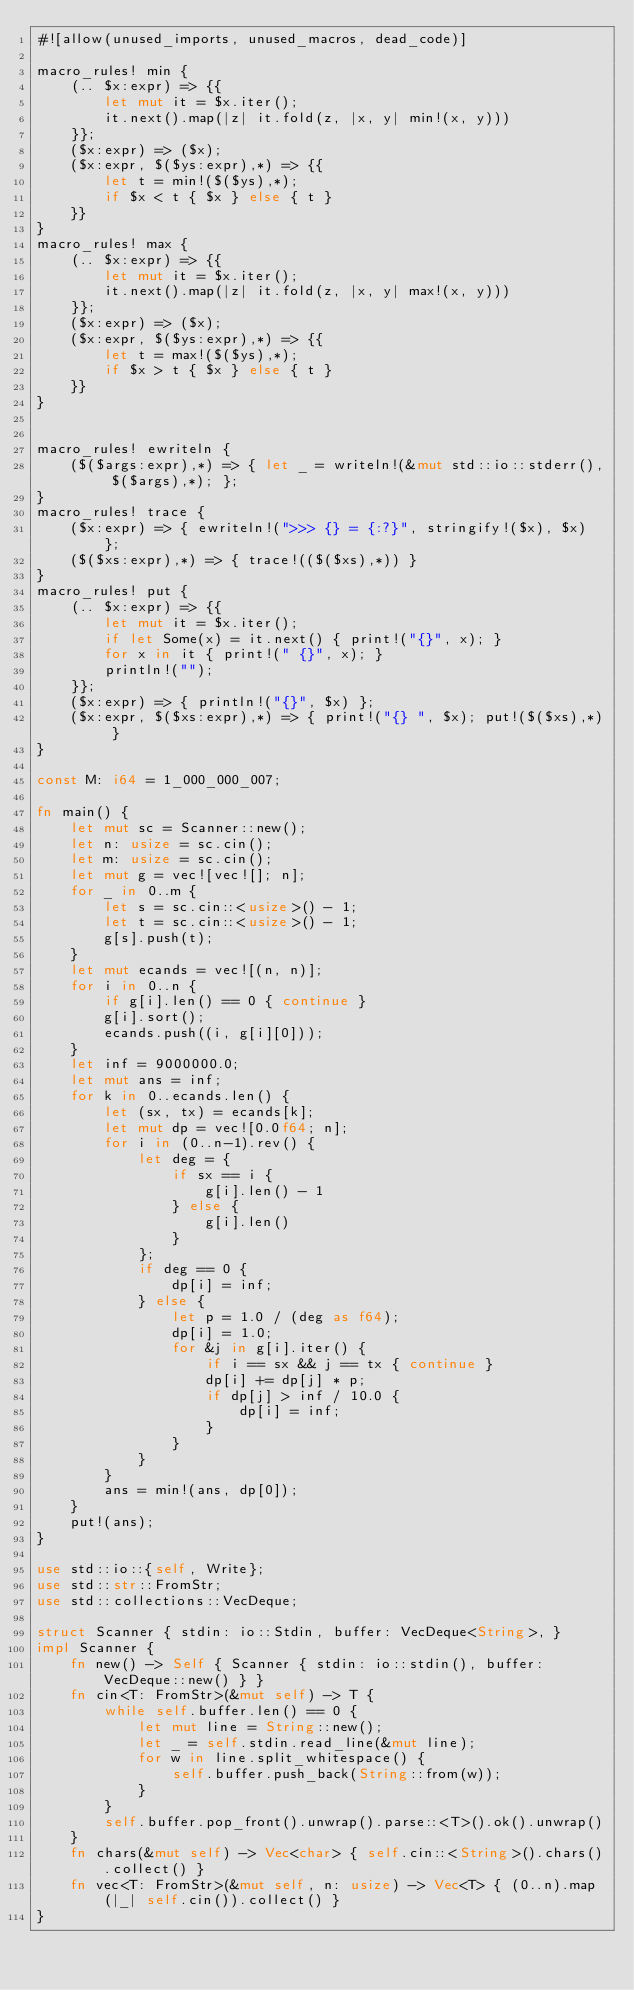Convert code to text. <code><loc_0><loc_0><loc_500><loc_500><_Rust_>#![allow(unused_imports, unused_macros, dead_code)]

macro_rules! min {
    (.. $x:expr) => {{
        let mut it = $x.iter();
        it.next().map(|z| it.fold(z, |x, y| min!(x, y)))
    }};
    ($x:expr) => ($x);
    ($x:expr, $($ys:expr),*) => {{
        let t = min!($($ys),*);
        if $x < t { $x } else { t }
    }}
}
macro_rules! max {
    (.. $x:expr) => {{
        let mut it = $x.iter();
        it.next().map(|z| it.fold(z, |x, y| max!(x, y)))
    }};
    ($x:expr) => ($x);
    ($x:expr, $($ys:expr),*) => {{
        let t = max!($($ys),*);
        if $x > t { $x } else { t }
    }}
}


macro_rules! ewriteln {
    ($($args:expr),*) => { let _ = writeln!(&mut std::io::stderr(), $($args),*); };
}
macro_rules! trace {
    ($x:expr) => { ewriteln!(">>> {} = {:?}", stringify!($x), $x) };
    ($($xs:expr),*) => { trace!(($($xs),*)) }
}
macro_rules! put {
    (.. $x:expr) => {{
        let mut it = $x.iter();
        if let Some(x) = it.next() { print!("{}", x); }
        for x in it { print!(" {}", x); }
        println!("");
    }};
    ($x:expr) => { println!("{}", $x) };
    ($x:expr, $($xs:expr),*) => { print!("{} ", $x); put!($($xs),*) }
}

const M: i64 = 1_000_000_007;

fn main() {
    let mut sc = Scanner::new();
    let n: usize = sc.cin();
    let m: usize = sc.cin();
    let mut g = vec![vec![]; n];
    for _ in 0..m {
        let s = sc.cin::<usize>() - 1;
        let t = sc.cin::<usize>() - 1;
        g[s].push(t);
    }
    let mut ecands = vec![(n, n)];
    for i in 0..n {
        if g[i].len() == 0 { continue }
        g[i].sort();
        ecands.push((i, g[i][0]));
    }
    let inf = 9000000.0;
    let mut ans = inf;
    for k in 0..ecands.len() {
        let (sx, tx) = ecands[k];
        let mut dp = vec![0.0f64; n];
        for i in (0..n-1).rev() {
            let deg = {
                if sx == i {
                    g[i].len() - 1
                } else {
                    g[i].len()
                }
            };
            if deg == 0 {
                dp[i] = inf;
            } else {
                let p = 1.0 / (deg as f64);
                dp[i] = 1.0;
                for &j in g[i].iter() {
                    if i == sx && j == tx { continue }
                    dp[i] += dp[j] * p;
                    if dp[j] > inf / 10.0 {
                        dp[i] = inf;
                    }
                }
            }
        }
        ans = min!(ans, dp[0]);
    }
    put!(ans);
}

use std::io::{self, Write};
use std::str::FromStr;
use std::collections::VecDeque;

struct Scanner { stdin: io::Stdin, buffer: VecDeque<String>, }
impl Scanner {
    fn new() -> Self { Scanner { stdin: io::stdin(), buffer: VecDeque::new() } }
    fn cin<T: FromStr>(&mut self) -> T {
        while self.buffer.len() == 0 {
            let mut line = String::new();
            let _ = self.stdin.read_line(&mut line);
            for w in line.split_whitespace() {
                self.buffer.push_back(String::from(w));
            }
        }
        self.buffer.pop_front().unwrap().parse::<T>().ok().unwrap()
    }
    fn chars(&mut self) -> Vec<char> { self.cin::<String>().chars().collect() }
    fn vec<T: FromStr>(&mut self, n: usize) -> Vec<T> { (0..n).map(|_| self.cin()).collect() }
}
</code> 